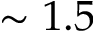Convert formula to latex. <formula><loc_0><loc_0><loc_500><loc_500>\sim 1 . 5</formula> 